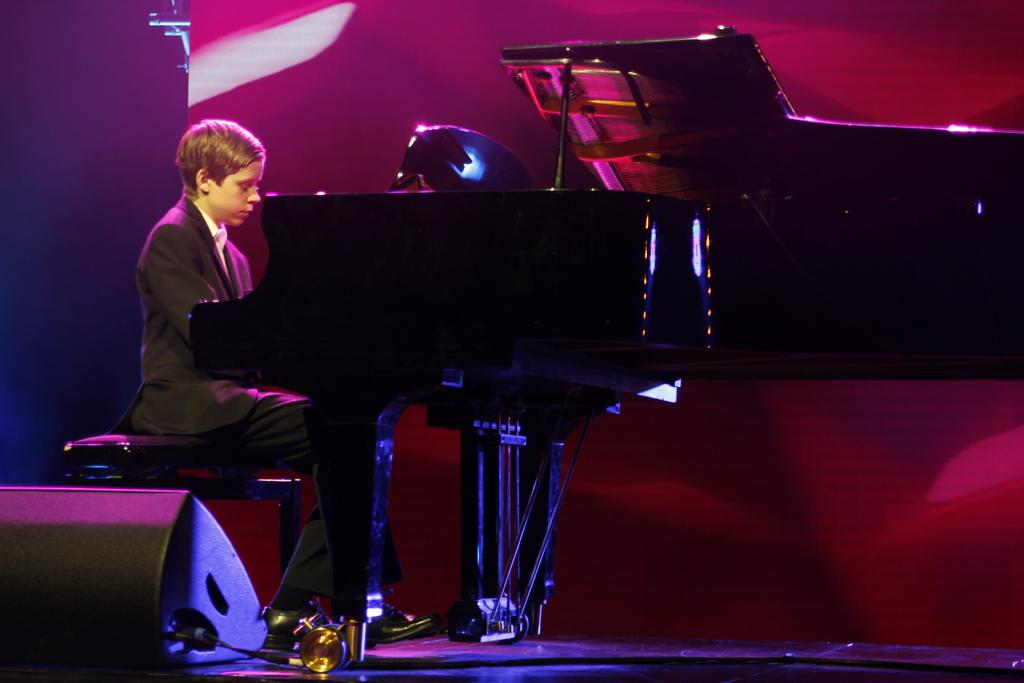Who is the main subject in the image? There is a boy in the image. What is the boy doing in the image? The boy is sitting on a chair and playing a piano. What is the boy wearing in the image? The boy is wearing a blazer and shoes. What type of chess piece is the boy holding in the image? There is no chess piece present in the image; the boy is playing a piano. Is the boy acting as a beggar in the image? No, the boy is not a beggar in the image; he is dressed in a blazer and playing a piano. 